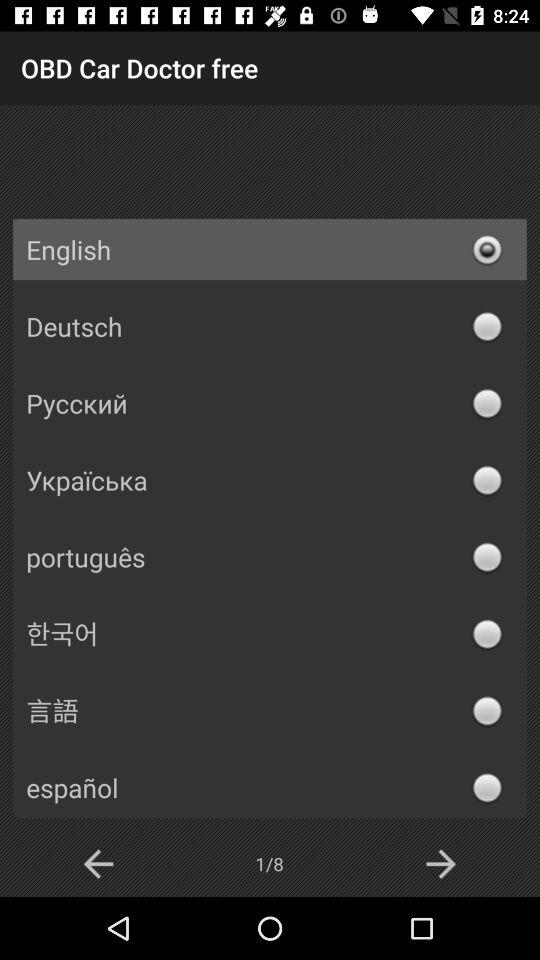Which option is selected? The selected option is "English". 